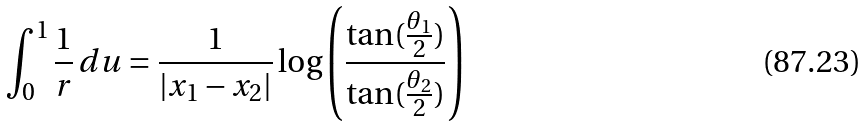<formula> <loc_0><loc_0><loc_500><loc_500>\int _ { 0 } ^ { 1 } \frac { 1 } { r } \, d u = \frac { 1 } { | { x } _ { 1 } - { x } _ { 2 } | } \log \left ( \frac { \tan ( \frac { \theta _ { 1 } } { 2 } ) } { \tan ( \frac { \theta _ { 2 } } { 2 } ) } \right )</formula> 